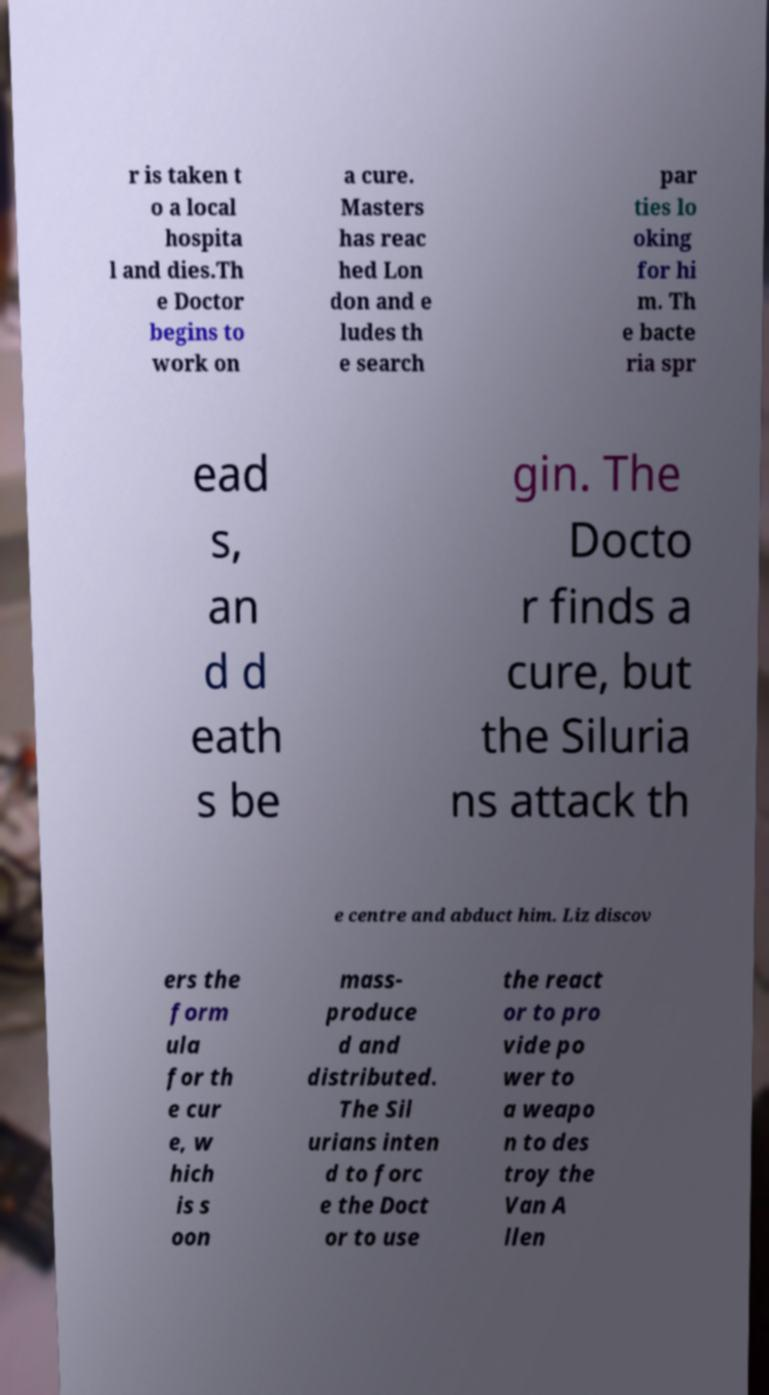What messages or text are displayed in this image? I need them in a readable, typed format. r is taken t o a local hospita l and dies.Th e Doctor begins to work on a cure. Masters has reac hed Lon don and e ludes th e search par ties lo oking for hi m. Th e bacte ria spr ead s, an d d eath s be gin. The Docto r finds a cure, but the Siluria ns attack th e centre and abduct him. Liz discov ers the form ula for th e cur e, w hich is s oon mass- produce d and distributed. The Sil urians inten d to forc e the Doct or to use the react or to pro vide po wer to a weapo n to des troy the Van A llen 